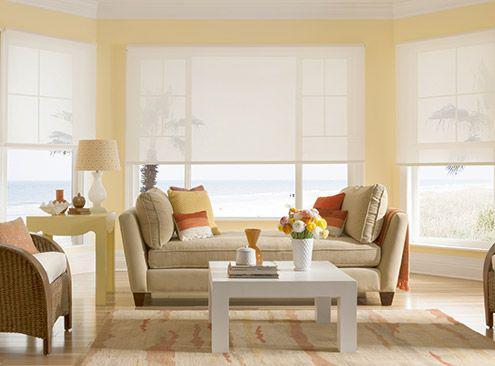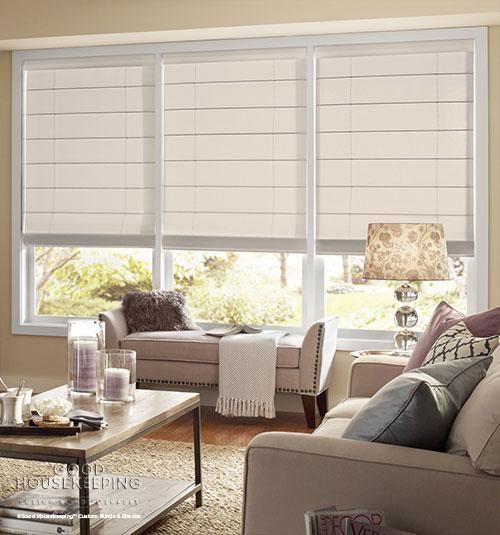The first image is the image on the left, the second image is the image on the right. Examine the images to the left and right. Is the description "The right image features windows covered by at least one dark brown shade." accurate? Answer yes or no. No. 